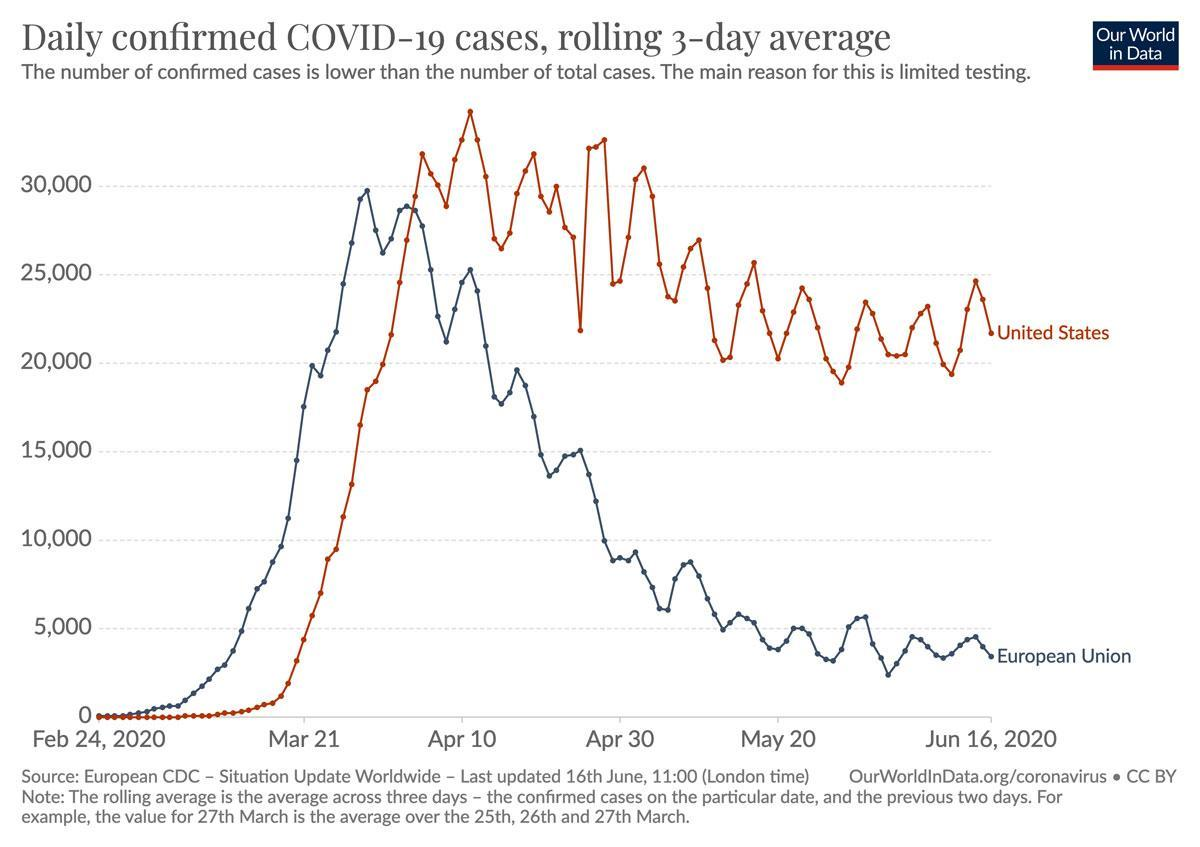Which color is used to represent the united states-blue, red, white?
Answer the question with a short phrase. red What is the total confirmed cases? 105,000 